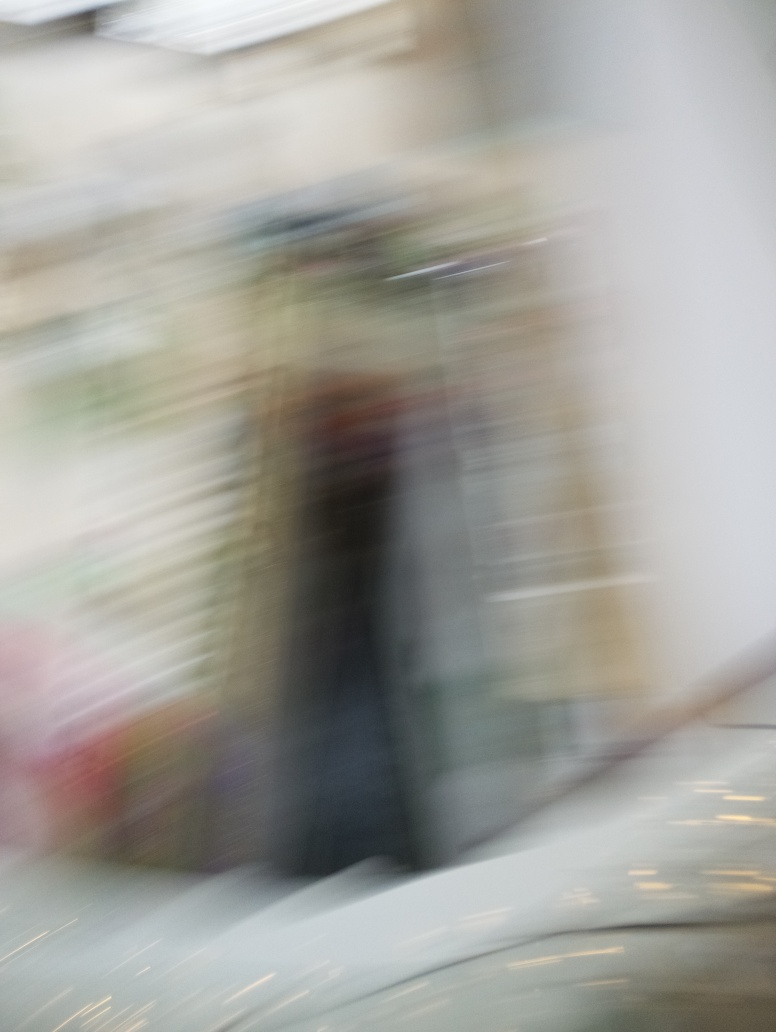Can you describe what might have caused the blur in this image? The blur in the image likely results from motion during the image capture. This could be caused by either the camera moving quickly, say during a pan or a shaky hold, or by the subject itself moving swiftly, giving rise to the smeared or ghosted appearance of details. 